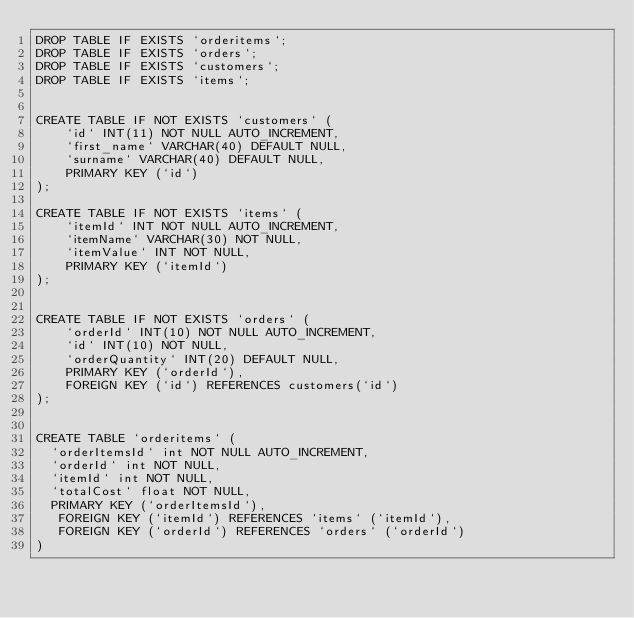<code> <loc_0><loc_0><loc_500><loc_500><_SQL_>DROP TABLE IF EXISTS `orderitems`;
DROP TABLE IF EXISTS `orders`;
DROP TABLE IF EXISTS `customers`;
DROP TABLE IF EXISTS `items`;


CREATE TABLE IF NOT EXISTS `customers` (
    `id` INT(11) NOT NULL AUTO_INCREMENT,
    `first_name` VARCHAR(40) DEFAULT NULL,
    `surname` VARCHAR(40) DEFAULT NULL,
    PRIMARY KEY (`id`)
);

CREATE TABLE IF NOT EXISTS `items` (
    `itemId` INT NOT NULL AUTO_INCREMENT,
    `itemName` VARCHAR(30) NOT NULL,
    `itemValue` INT NOT NULL,
    PRIMARY KEY (`itemId`)
);


CREATE TABLE IF NOT EXISTS `orders` (
    `orderId` INT(10) NOT NULL AUTO_INCREMENT,
    `id` INT(10) NOT NULL,
    `orderQuantity` INT(20) DEFAULT NULL,
    PRIMARY KEY (`orderId`),
    FOREIGN KEY (`id`) REFERENCES customers(`id`)
);


CREATE TABLE `orderitems` (
  `orderItemsId` int NOT NULL AUTO_INCREMENT,
  `orderId` int NOT NULL,
  `itemId` int NOT NULL,
  `totalCost` float NOT NULL,
  PRIMARY KEY (`orderItemsId`),
   FOREIGN KEY (`itemId`) REFERENCES `items` (`itemId`),
   FOREIGN KEY (`orderId`) REFERENCES `orders` (`orderId`)
) 
</code> 